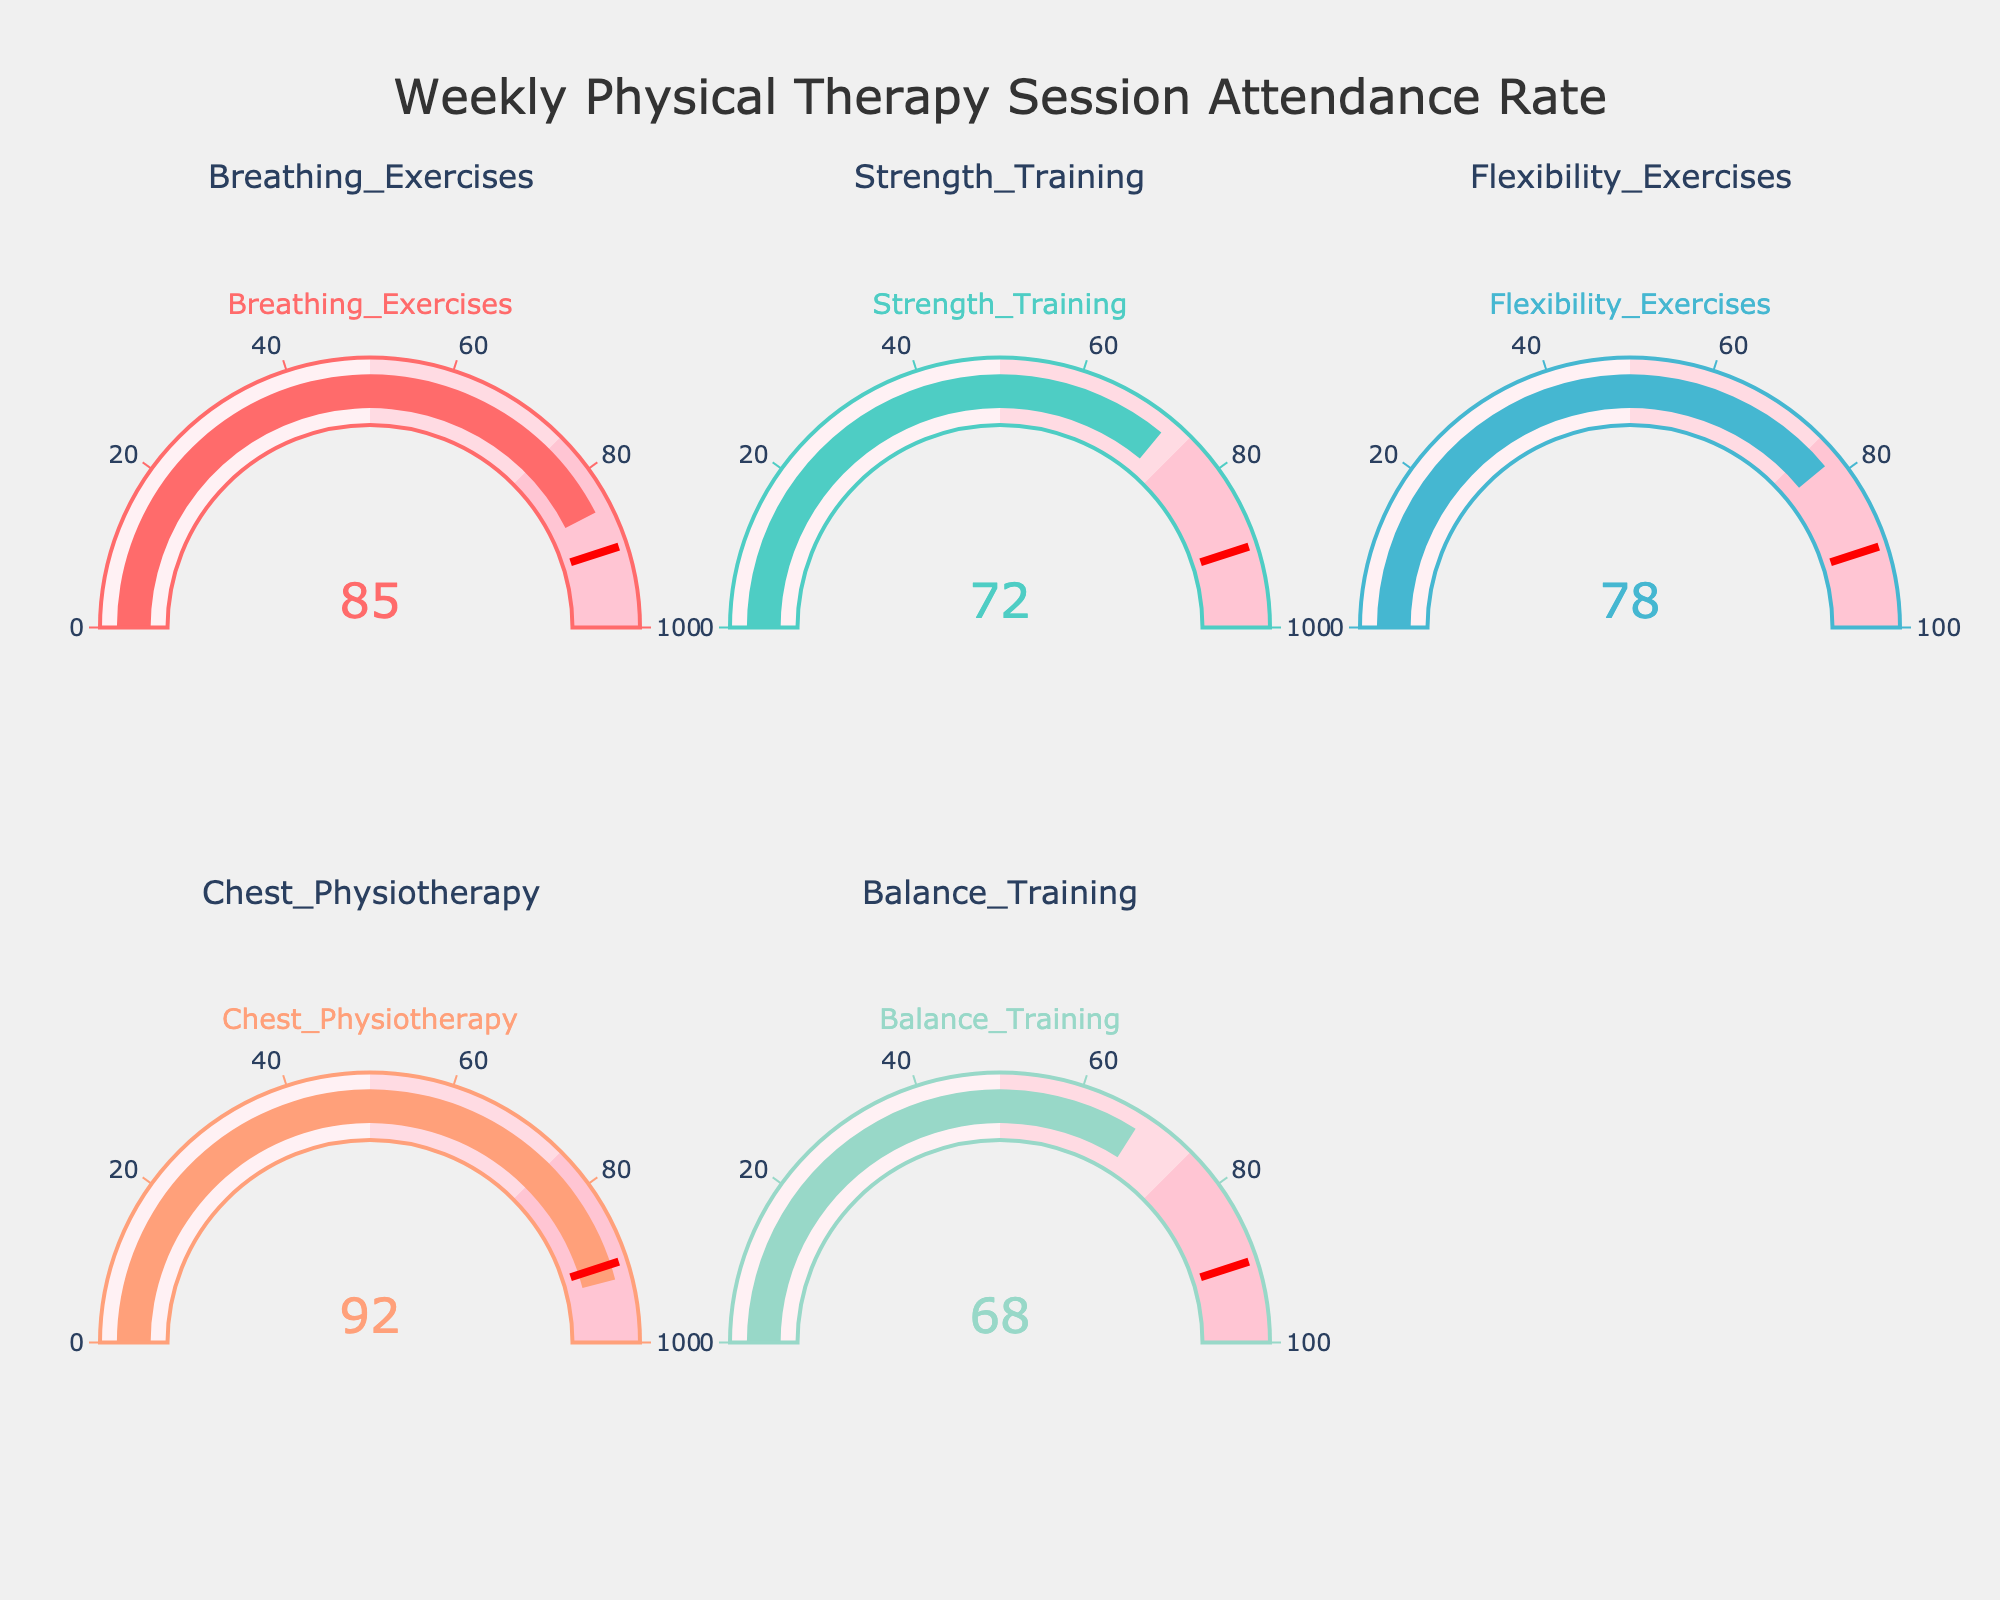What's the title of the figure? The title is prominently displayed at the top of the figure, stating the main topic of the visualization: "Weekly Physical Therapy Session Attendance Rate."
Answer: Weekly Physical Therapy Session Attendance Rate Which session type has the highest attendance rate? To find the highest attendance rate, look at the displayed values in each gauge. The gauge with the value 92 represents the highest rate. The session type for this gauge is "Chest Physiotherapy."
Answer: Chest Physiotherapy What is the attendance rate for Strength Training? Locate the gauge titled "Strength Training." The number displayed on this gauge is the attendance rate: 72.
Answer: 72 How many different physical therapy session types are shown in the figure? Count the number of unique gauge titles listed, each representing a different session type. There are five titles: Breathing Exercises, Strength Training, Flexibility Exercises, Chest Physiotherapy, and Balance Training.
Answer: 5 What is the average attendance rate for all the session types? Add up all the attendance rates (85, 72, 78, 92, 68) and divide by the total number of session types (5). (85 + 72 + 78 + 92 + 68) / 5 = 79
Answer: 79 Which session type falls below the threshold of 90? The threshold is marked by a red line on each gauge at the value 90. All gauges below this line are below the threshold. The session types below 90 are Breathing Exercises (85), Strength Training (72), Flexibility Exercises (78), and Balance Training (68).
Answer: Breathing Exercises, Strength Training, Flexibility Exercises, Balance Training Which session type has the lowest attendance rate? Locate the gauge with the smallest displayed number. The number 68 is the lowest and corresponds to the "Balance Training" session.
Answer: Balance Training How does the attendance rate for Flexibility Exercises compare to that of Breathing Exercises? Compare the numbers on the gauges for Flexibility Exercises (78) and Breathing Exercises (85). Flexibility Exercises have a lower attendance rate than Breathing Exercises.
Answer: Flexibility Exercises < Breathing Exercises 